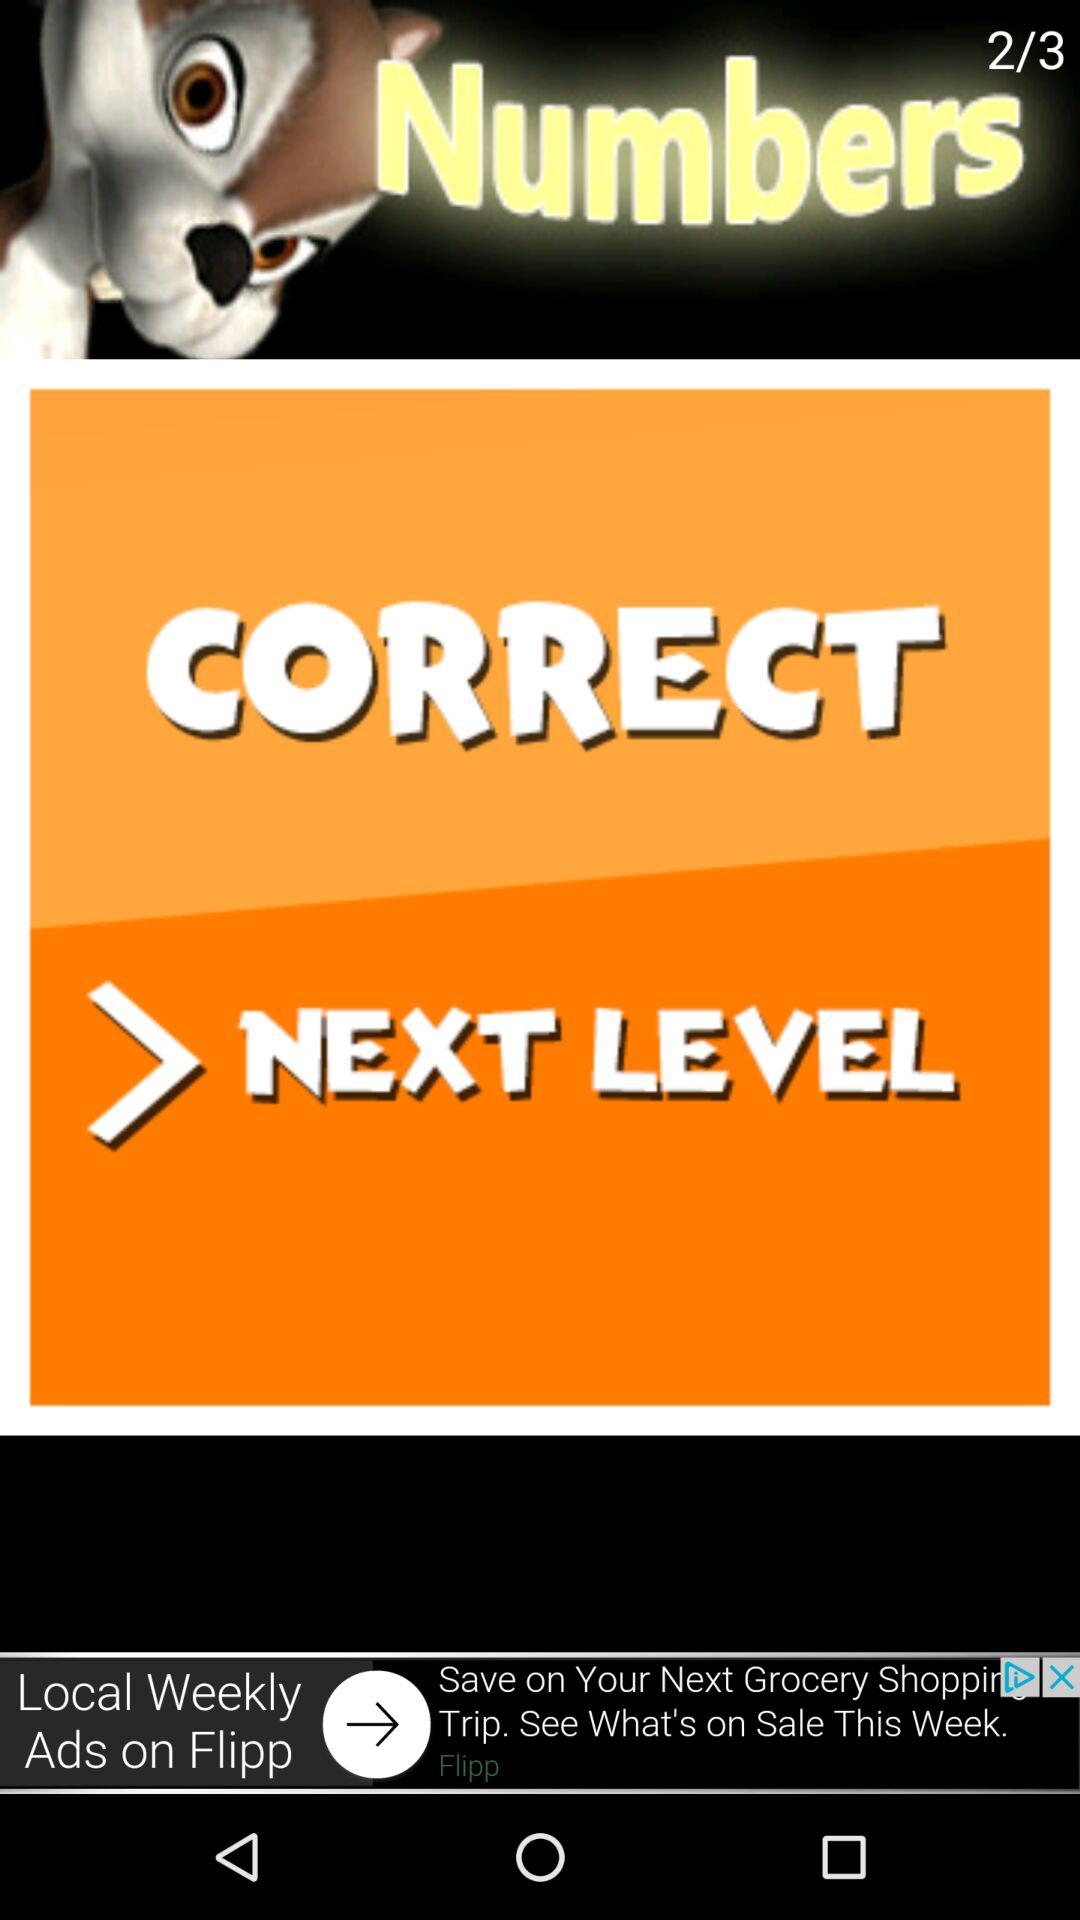What is the total number of levels in numbers? The total number of levels is 3. 